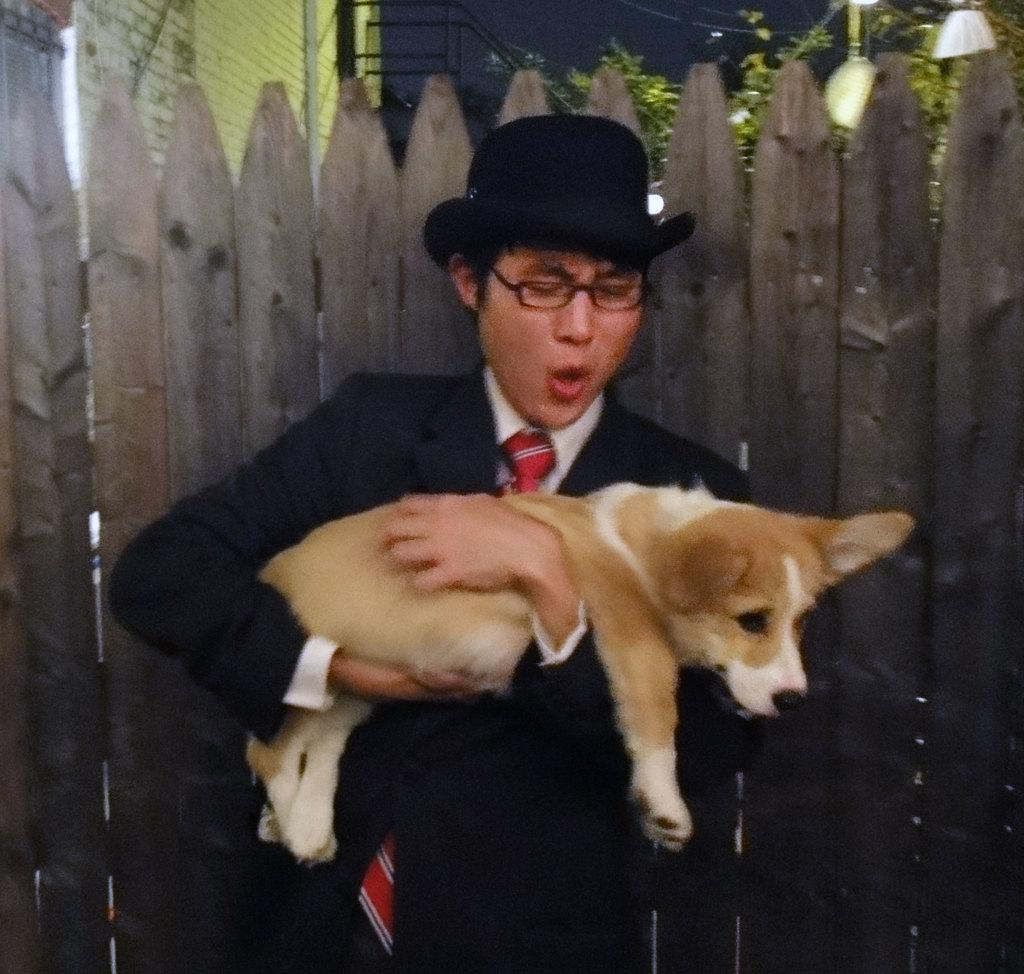What is the person in the image doing? The person is standing in the image and holding a dog. Can you describe the person's appearance? The person is wearing glasses and a hat. What can be seen in the background of the image? There are trees, a wall, and a wooden fence in the background of the image. What type of calculator is the person using to solve the soup recipe in the image? There is no calculator or soup recipe present in the image. The person is simply holding a dog and standing with them. 